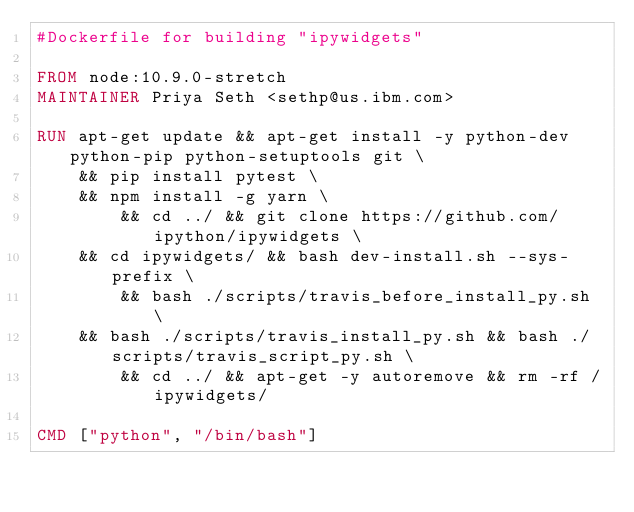<code> <loc_0><loc_0><loc_500><loc_500><_Dockerfile_>#Dockerfile for building "ipywidgets"

FROM node:10.9.0-stretch
MAINTAINER Priya Seth <sethp@us.ibm.com>

RUN apt-get update && apt-get install -y python-dev python-pip python-setuptools git \
	&& pip install pytest \
	&& npm install -g yarn \
        && cd ../ && git clone https://github.com/ipython/ipywidgets \
	&& cd ipywidgets/ && bash dev-install.sh --sys-prefix \
        && bash ./scripts/travis_before_install_py.sh \
	&& bash ./scripts/travis_install_py.sh && bash ./scripts/travis_script_py.sh \
        && cd ../ && apt-get -y autoremove && rm -rf /ipywidgets/

CMD ["python", "/bin/bash"]

</code> 